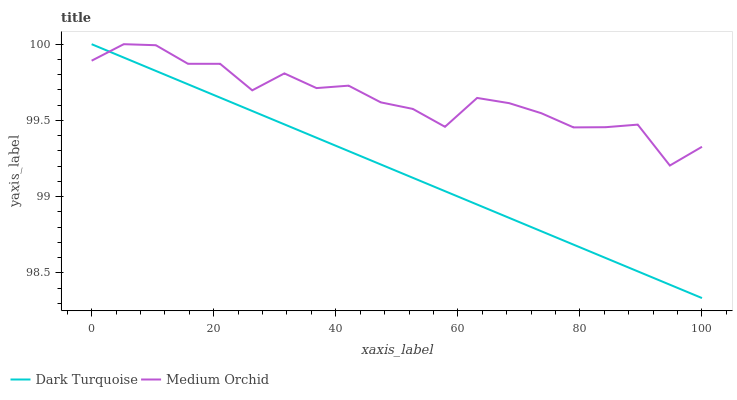Does Dark Turquoise have the minimum area under the curve?
Answer yes or no. Yes. Does Medium Orchid have the maximum area under the curve?
Answer yes or no. Yes. Does Medium Orchid have the minimum area under the curve?
Answer yes or no. No. Is Dark Turquoise the smoothest?
Answer yes or no. Yes. Is Medium Orchid the roughest?
Answer yes or no. Yes. Is Medium Orchid the smoothest?
Answer yes or no. No. Does Dark Turquoise have the lowest value?
Answer yes or no. Yes. Does Medium Orchid have the lowest value?
Answer yes or no. No. Does Medium Orchid have the highest value?
Answer yes or no. Yes. Does Dark Turquoise intersect Medium Orchid?
Answer yes or no. Yes. Is Dark Turquoise less than Medium Orchid?
Answer yes or no. No. Is Dark Turquoise greater than Medium Orchid?
Answer yes or no. No. 